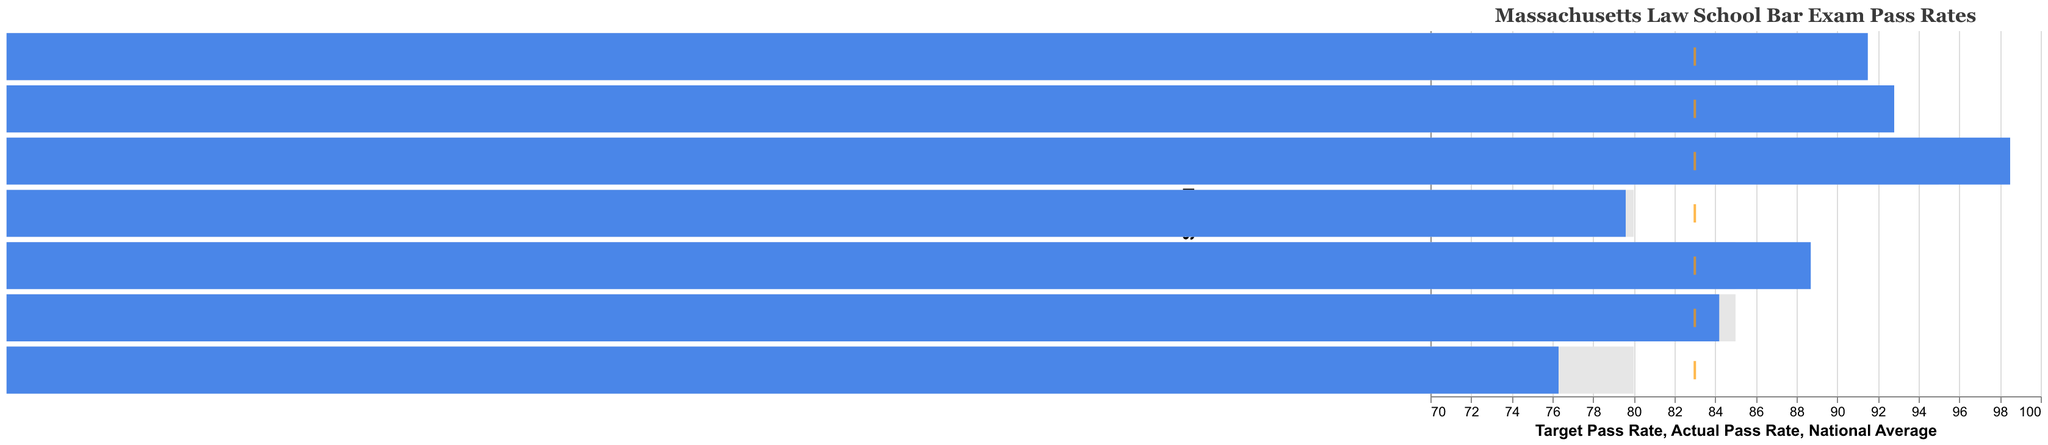What is the title of the chart? The title of the chart can be found at the top of the figure.
Answer: Massachusetts Law School Bar Exam Pass Rates Which school has the highest actual pass rate? Look for the bar with the highest value for "Actual Pass Rate".
Answer: Harvard Law School What color represents the target pass rates? Identify the color used for the bars corresponding to the "Target Pass Rate".
Answer: Light gray What is the actual pass rate of Suffolk University Law School? Refer to the length of the blue bar for Suffolk University Law School.
Answer: 84.2 Which school has an actual pass rate closest to the national average? Look for the bar closest to the orange tick representing the national average (83%).
Answer: Suffolk University Law School How many schools have an actual pass rate higher than their target pass rate? Count the number of schools where the blue bar is longer than the light gray bar.
Answer: Four schools By how much does Harvard Law School's actual pass rate exceed the national average? Subtract the national average from Harvard Law School's actual pass rate. 98.5 - 83 = 15.5
Answer: 15.5 What's the difference between the actual pass rate of Northeastern University School of Law and Western New England University School of Law? Subtract the actual pass rate of Western New England University School of Law from Northeastern University School of Law. 88.7 - 76.3 = 12.4
Answer: 12.4 What is the average actual pass rate of all the schools? Sum all the actual pass rates and divide by the number of schools. (98.5 + 92.8 + 91.5 + 88.7 + 84.2 + 79.6 + 76.3) / 7 = 87.37
Answer: 87.37 Which school's actual pass rate is exactly equal to its target pass rate? Compare the blue and light gray bars for each school to find those that are equal in length.
Answer: None 